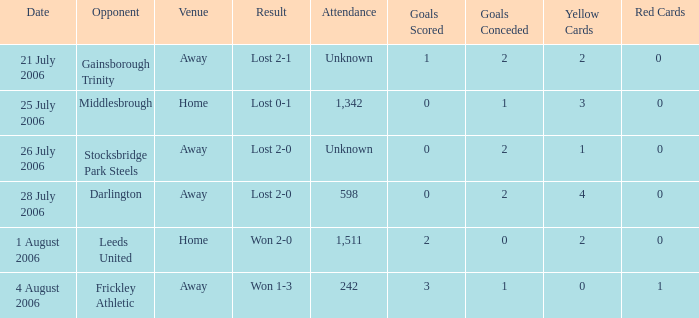What is the result from the Leeds United opponent? Won 2-0. 